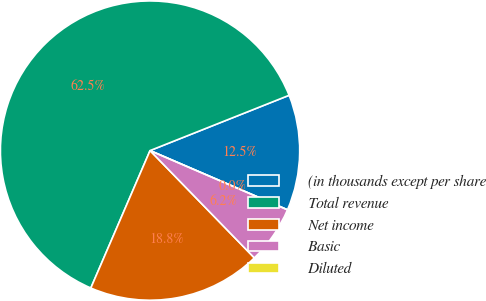Convert chart. <chart><loc_0><loc_0><loc_500><loc_500><pie_chart><fcel>(in thousands except per share<fcel>Total revenue<fcel>Net income<fcel>Basic<fcel>Diluted<nl><fcel>12.5%<fcel>62.5%<fcel>18.75%<fcel>6.25%<fcel>0.0%<nl></chart> 